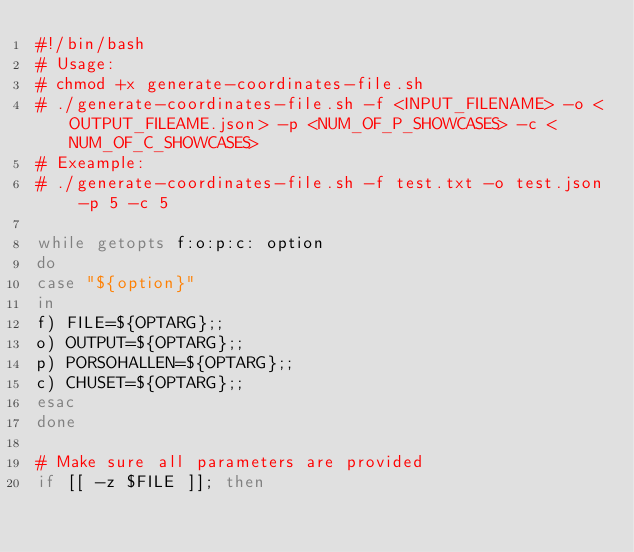<code> <loc_0><loc_0><loc_500><loc_500><_Bash_>#!/bin/bash
# Usage:
# chmod +x generate-coordinates-file.sh
# ./generate-coordinates-file.sh -f <INPUT_FILENAME> -o <OUTPUT_FILEAME.json> -p <NUM_OF_P_SHOWCASES> -c <NUM_OF_C_SHOWCASES>
# Exeample:
# ./generate-coordinates-file.sh -f test.txt -o test.json -p 5 -c 5

while getopts f:o:p:c: option
do
case "${option}"
in
f) FILE=${OPTARG};;
o) OUTPUT=${OPTARG};;
p) PORSOHALLEN=${OPTARG};;
c) CHUSET=${OPTARG};;
esac
done

# Make sure all parameters are provided
if [[ -z $FILE ]]; then</code> 